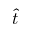<formula> <loc_0><loc_0><loc_500><loc_500>\hat { t }</formula> 